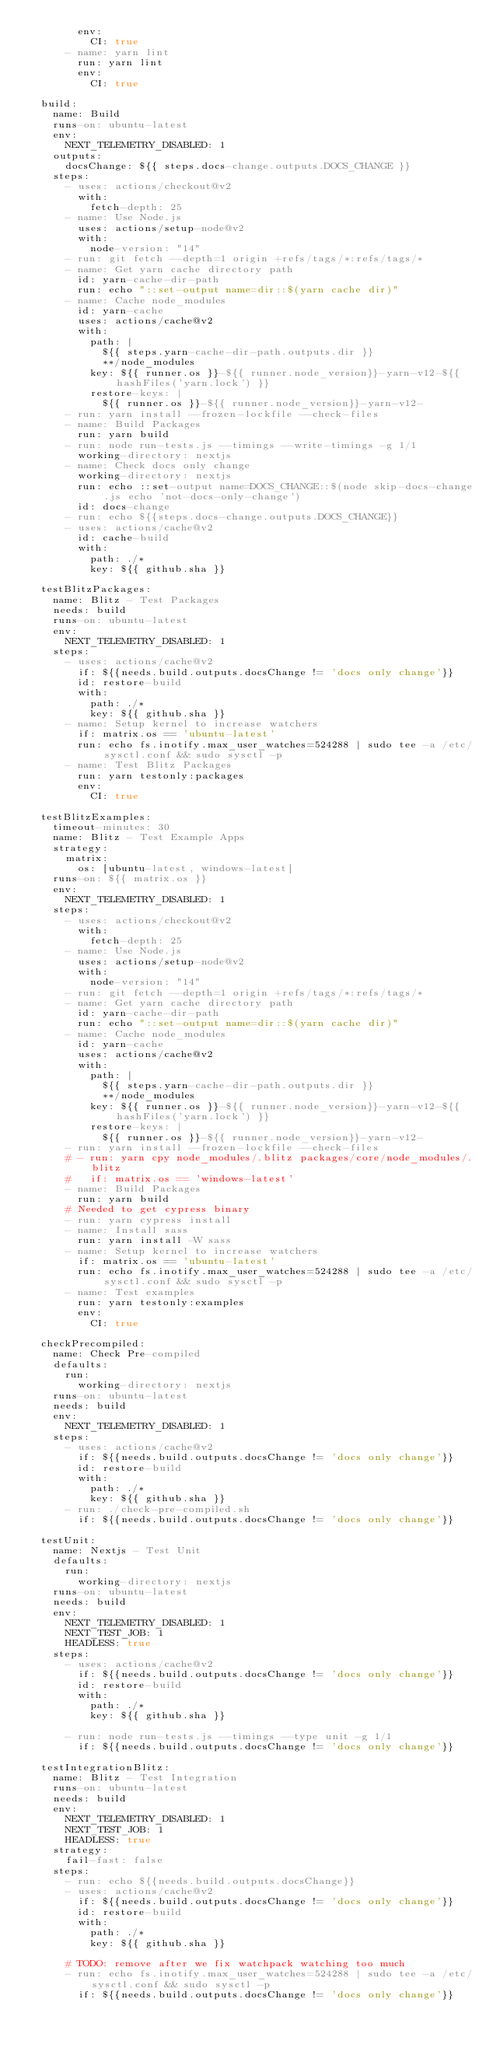Convert code to text. <code><loc_0><loc_0><loc_500><loc_500><_YAML_>        env:
          CI: true
      - name: yarn lint
        run: yarn lint
        env:
          CI: true

  build:
    name: Build
    runs-on: ubuntu-latest
    env:
      NEXT_TELEMETRY_DISABLED: 1
    outputs:
      docsChange: ${{ steps.docs-change.outputs.DOCS_CHANGE }}
    steps:
      - uses: actions/checkout@v2
        with:
          fetch-depth: 25
      - name: Use Node.js
        uses: actions/setup-node@v2
        with:
          node-version: "14"
      - run: git fetch --depth=1 origin +refs/tags/*:refs/tags/*
      - name: Get yarn cache directory path
        id: yarn-cache-dir-path
        run: echo "::set-output name=dir::$(yarn cache dir)"
      - name: Cache node_modules
        id: yarn-cache
        uses: actions/cache@v2
        with:
          path: |
            ${{ steps.yarn-cache-dir-path.outputs.dir }}
            **/node_modules
          key: ${{ runner.os }}-${{ runner.node_version}}-yarn-v12-${{ hashFiles('yarn.lock') }}
          restore-keys: |
            ${{ runner.os }}-${{ runner.node_version}}-yarn-v12-
      - run: yarn install --frozen-lockfile --check-files
      - name: Build Packages
        run: yarn build
      - run: node run-tests.js --timings --write-timings -g 1/1
        working-directory: nextjs
      - name: Check docs only change
        working-directory: nextjs
        run: echo ::set-output name=DOCS_CHANGE::$(node skip-docs-change.js echo 'not-docs-only-change')
        id: docs-change
      - run: echo ${{steps.docs-change.outputs.DOCS_CHANGE}}
      - uses: actions/cache@v2
        id: cache-build
        with:
          path: ./*
          key: ${{ github.sha }}

  testBlitzPackages:
    name: Blitz - Test Packages
    needs: build
    runs-on: ubuntu-latest
    env:
      NEXT_TELEMETRY_DISABLED: 1
    steps:
      - uses: actions/cache@v2
        if: ${{needs.build.outputs.docsChange != 'docs only change'}}
        id: restore-build
        with:
          path: ./*
          key: ${{ github.sha }}
      - name: Setup kernel to increase watchers
        if: matrix.os == 'ubuntu-latest'
        run: echo fs.inotify.max_user_watches=524288 | sudo tee -a /etc/sysctl.conf && sudo sysctl -p
      - name: Test Blitz Packages
        run: yarn testonly:packages
        env:
          CI: true

  testBlitzExamples:
    timeout-minutes: 30
    name: Blitz - Test Example Apps
    strategy:
      matrix:
        os: [ubuntu-latest, windows-latest]
    runs-on: ${{ matrix.os }}
    env:
      NEXT_TELEMETRY_DISABLED: 1
    steps:
      - uses: actions/checkout@v2
        with:
          fetch-depth: 25
      - name: Use Node.js
        uses: actions/setup-node@v2
        with:
          node-version: "14"
      - run: git fetch --depth=1 origin +refs/tags/*:refs/tags/*
      - name: Get yarn cache directory path
        id: yarn-cache-dir-path
        run: echo "::set-output name=dir::$(yarn cache dir)"
      - name: Cache node_modules
        id: yarn-cache
        uses: actions/cache@v2
        with:
          path: |
            ${{ steps.yarn-cache-dir-path.outputs.dir }}
            **/node_modules
          key: ${{ runner.os }}-${{ runner.node_version}}-yarn-v12-${{ hashFiles('yarn.lock') }}
          restore-keys: |
            ${{ runner.os }}-${{ runner.node_version}}-yarn-v12-
      - run: yarn install --frozen-lockfile --check-files
      # - run: yarn cpy node_modules/.blitz packages/core/node_modules/.blitz
      #   if: matrix.os == 'windows-latest'
      - name: Build Packages
        run: yarn build
      # Needed to get cypress binary
      - run: yarn cypress install
      - name: Install sass
        run: yarn install -W sass
      - name: Setup kernel to increase watchers
        if: matrix.os == 'ubuntu-latest'
        run: echo fs.inotify.max_user_watches=524288 | sudo tee -a /etc/sysctl.conf && sudo sysctl -p
      - name: Test examples
        run: yarn testonly:examples
        env:
          CI: true

  checkPrecompiled:
    name: Check Pre-compiled
    defaults:
      run:
        working-directory: nextjs
    runs-on: ubuntu-latest
    needs: build
    env:
      NEXT_TELEMETRY_DISABLED: 1
    steps:
      - uses: actions/cache@v2
        if: ${{needs.build.outputs.docsChange != 'docs only change'}}
        id: restore-build
        with:
          path: ./*
          key: ${{ github.sha }}
      - run: ./check-pre-compiled.sh
        if: ${{needs.build.outputs.docsChange != 'docs only change'}}

  testUnit:
    name: Nextjs - Test Unit
    defaults:
      run:
        working-directory: nextjs
    runs-on: ubuntu-latest
    needs: build
    env:
      NEXT_TELEMETRY_DISABLED: 1
      NEXT_TEST_JOB: 1
      HEADLESS: true
    steps:
      - uses: actions/cache@v2
        if: ${{needs.build.outputs.docsChange != 'docs only change'}}
        id: restore-build
        with:
          path: ./*
          key: ${{ github.sha }}

      - run: node run-tests.js --timings --type unit -g 1/1
        if: ${{needs.build.outputs.docsChange != 'docs only change'}}

  testIntegrationBlitz:
    name: Blitz - Test Integration
    runs-on: ubuntu-latest
    needs: build
    env:
      NEXT_TELEMETRY_DISABLED: 1
      NEXT_TEST_JOB: 1
      HEADLESS: true
    strategy:
      fail-fast: false
    steps:
      - run: echo ${{needs.build.outputs.docsChange}}
      - uses: actions/cache@v2
        if: ${{needs.build.outputs.docsChange != 'docs only change'}}
        id: restore-build
        with:
          path: ./*
          key: ${{ github.sha }}

      # TODO: remove after we fix watchpack watching too much
      - run: echo fs.inotify.max_user_watches=524288 | sudo tee -a /etc/sysctl.conf && sudo sysctl -p
        if: ${{needs.build.outputs.docsChange != 'docs only change'}}
</code> 